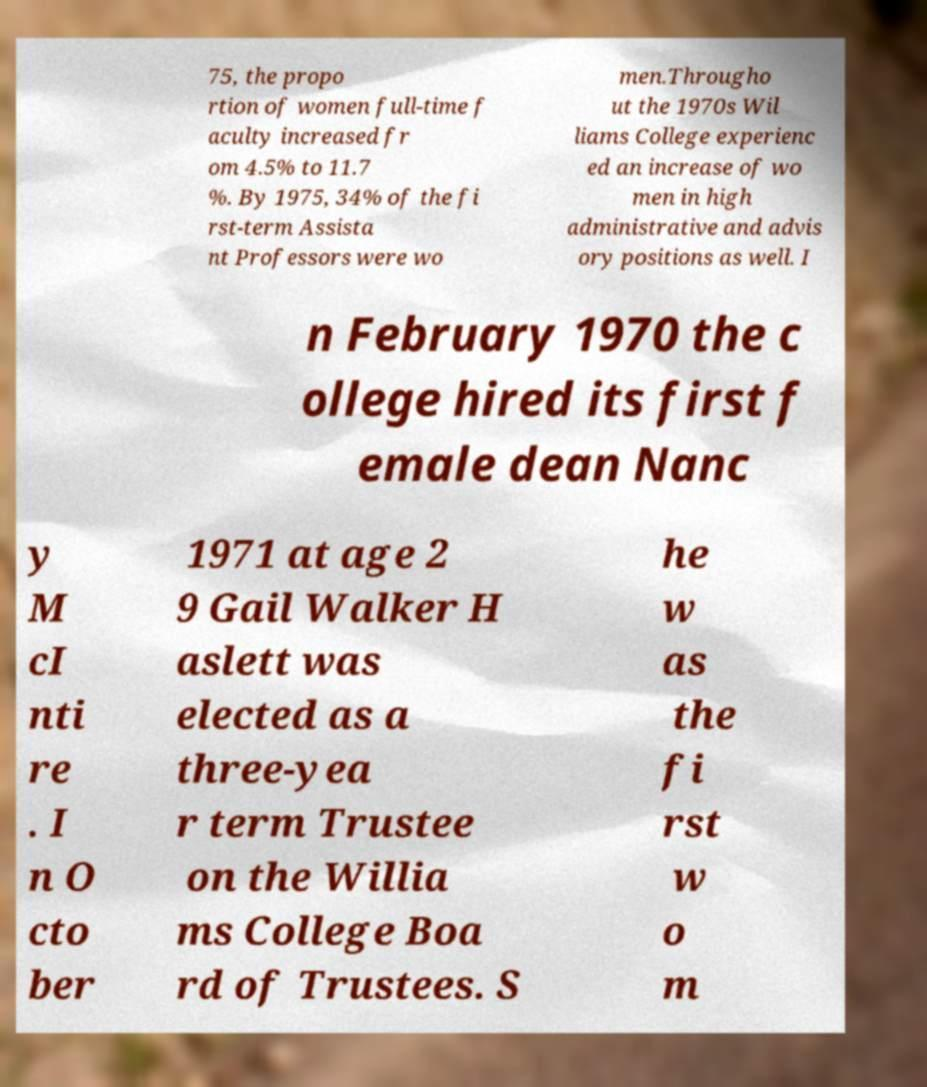Could you extract and type out the text from this image? 75, the propo rtion of women full-time f aculty increased fr om 4.5% to 11.7 %. By 1975, 34% of the fi rst-term Assista nt Professors were wo men.Througho ut the 1970s Wil liams College experienc ed an increase of wo men in high administrative and advis ory positions as well. I n February 1970 the c ollege hired its first f emale dean Nanc y M cI nti re . I n O cto ber 1971 at age 2 9 Gail Walker H aslett was elected as a three-yea r term Trustee on the Willia ms College Boa rd of Trustees. S he w as the fi rst w o m 